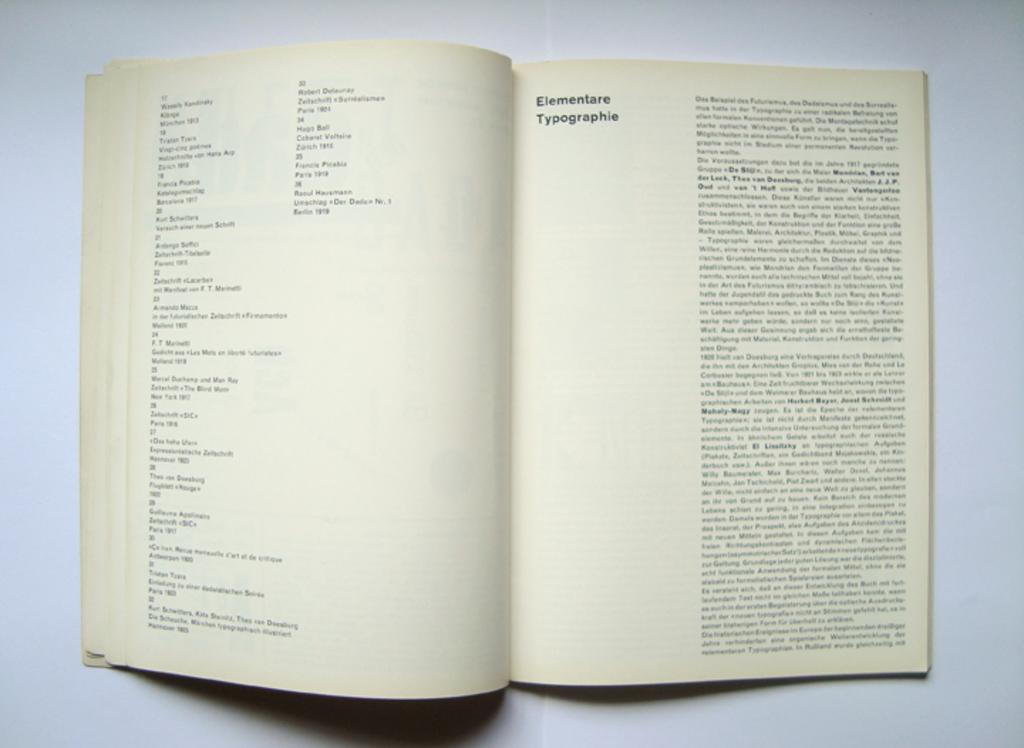What book is this?
Keep it short and to the point. Elementare typographie. Are there section in bold face print?
Provide a succinct answer. Yes. 